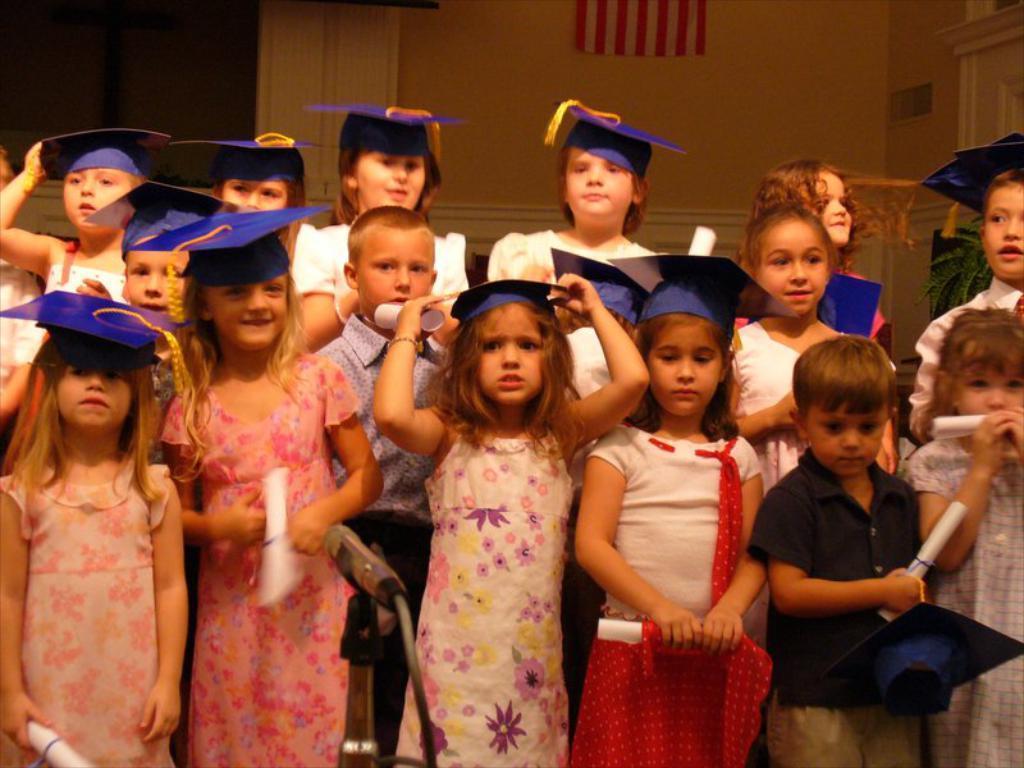Please provide a concise description of this image. In this image we can see these children wearing blue color hats and holding certificates in their hands are standing here. Here we can see the mic to the stand. In the background, we can see the wall. 